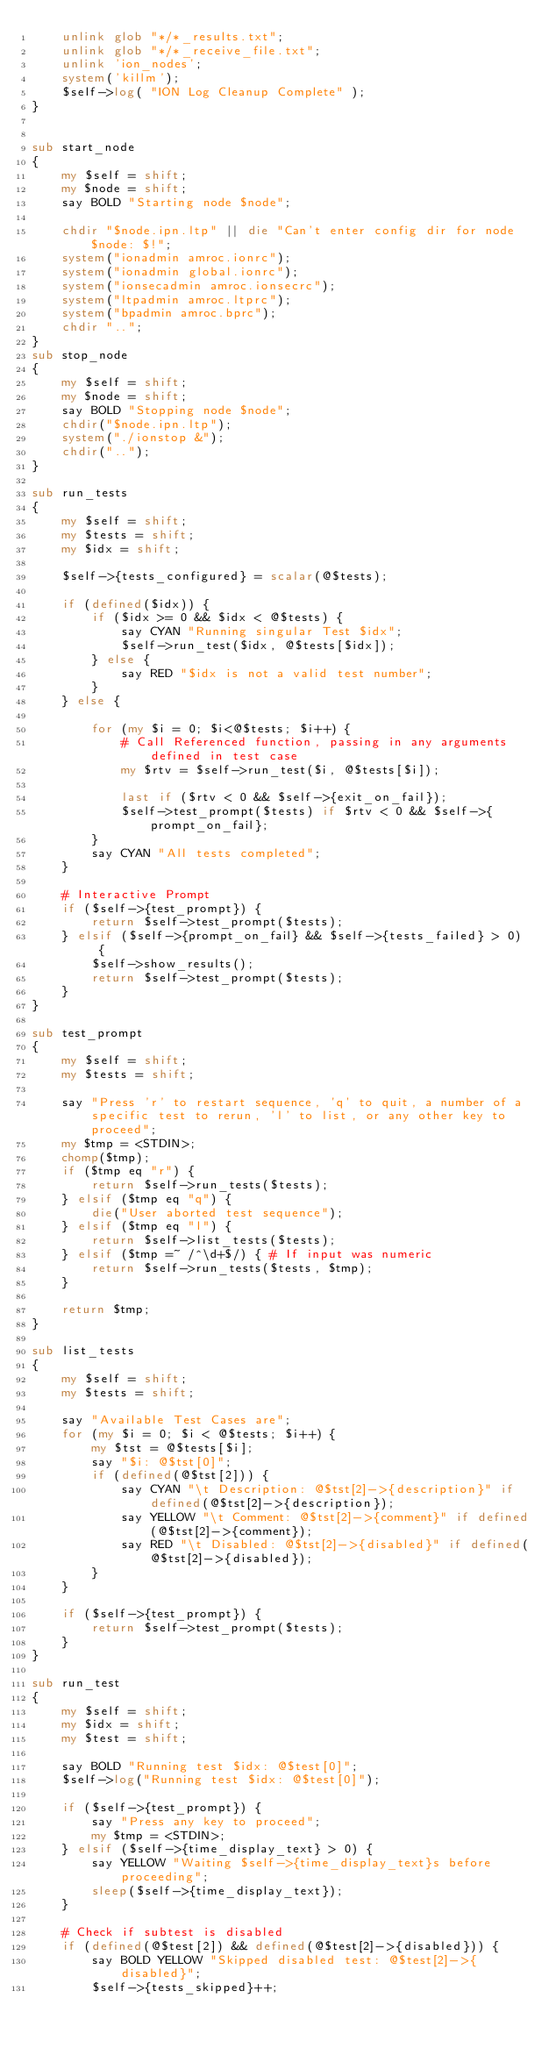<code> <loc_0><loc_0><loc_500><loc_500><_Perl_>    unlink glob "*/*_results.txt";
    unlink glob "*/*_receive_file.txt";
    unlink 'ion_nodes';
    system('killm');
    $self->log( "ION Log Cleanup Complete" );
}


sub start_node
{
    my $self = shift;
    my $node = shift;
    say BOLD "Starting node $node";

    chdir "$node.ipn.ltp" || die "Can't enter config dir for node $node: $!";
    system("ionadmin amroc.ionrc");
    system("ionadmin global.ionrc");
    system("ionsecadmin amroc.ionsecrc");
    system("ltpadmin amroc.ltprc");
    system("bpadmin amroc.bprc");
    chdir "..";
}
sub stop_node
{
    my $self = shift;
    my $node = shift;
    say BOLD "Stopping node $node";
    chdir("$node.ipn.ltp");
    system("./ionstop &");
    chdir("..");
}

sub run_tests
{
    my $self = shift;
    my $tests = shift;
    my $idx = shift;
    
    $self->{tests_configured} = scalar(@$tests);

    if (defined($idx)) {
        if ($idx >= 0 && $idx < @$tests) {
            say CYAN "Running singular Test $idx";
            $self->run_test($idx, @$tests[$idx]);
        } else {
            say RED "$idx is not a valid test number";
        }
    } else {
    
        for (my $i = 0; $i<@$tests; $i++) {
            # Call Referenced function, passing in any arguments defined in test case
            my $rtv = $self->run_test($i, @$tests[$i]);
            
            last if ($rtv < 0 && $self->{exit_on_fail});
            $self->test_prompt($tests) if $rtv < 0 && $self->{prompt_on_fail};
        }
        say CYAN "All tests completed";
    }

    # Interactive Prompt
    if ($self->{test_prompt}) {
        return $self->test_prompt($tests);
    } elsif ($self->{prompt_on_fail} && $self->{tests_failed} > 0)  {
        $self->show_results();
        return $self->test_prompt($tests);
    }
}

sub test_prompt
{
    my $self = shift;
    my $tests = shift;
    
    say "Press 'r' to restart sequence, 'q' to quit, a number of a specific test to rerun, 'l' to list, or any other key to proceed";
    my $tmp = <STDIN>;
    chomp($tmp);
    if ($tmp eq "r") {
        return $self->run_tests($tests);
    } elsif ($tmp eq "q") {
        die("User aborted test sequence");
    } elsif ($tmp eq "l") {
        return $self->list_tests($tests);
    } elsif ($tmp =~ /^\d+$/) { # If input was numeric
        return $self->run_tests($tests, $tmp);
    }

    return $tmp;
}

sub list_tests
{
    my $self = shift;
    my $tests = shift;

    say "Available Test Cases are";
    for (my $i = 0; $i < @$tests; $i++) {
        my $tst = @$tests[$i];
        say "$i: @$tst[0]";
        if (defined(@$tst[2])) {
            say CYAN "\t Description: @$tst[2]->{description}" if defined(@$tst[2]->{description});
            say YELLOW "\t Comment: @$tst[2]->{comment}" if defined(@$tst[2]->{comment});
            say RED "\t Disabled: @$tst[2]->{disabled}" if defined(@$tst[2]->{disabled});
        }
    }

    if ($self->{test_prompt}) {
        return $self->test_prompt($tests);
    }
}

sub run_test
{
    my $self = shift;
    my $idx = shift;
    my $test = shift;

    say BOLD "Running test $idx: @$test[0]";
    $self->log("Running test $idx: @$test[0]");
    
    if ($self->{test_prompt}) {
        say "Press any key to proceed";
        my $tmp = <STDIN>;
    } elsif ($self->{time_display_text} > 0) {
        say YELLOW "Waiting $self->{time_display_text}s before proceeding";
        sleep($self->{time_display_text});
    }

    # Check if subtest is disabled
    if (defined(@$test[2]) && defined(@$test[2]->{disabled})) {
        say BOLD YELLOW "Skipped disabled test: @$test[2]->{disabled}";
        $self->{tests_skipped}++;</code> 